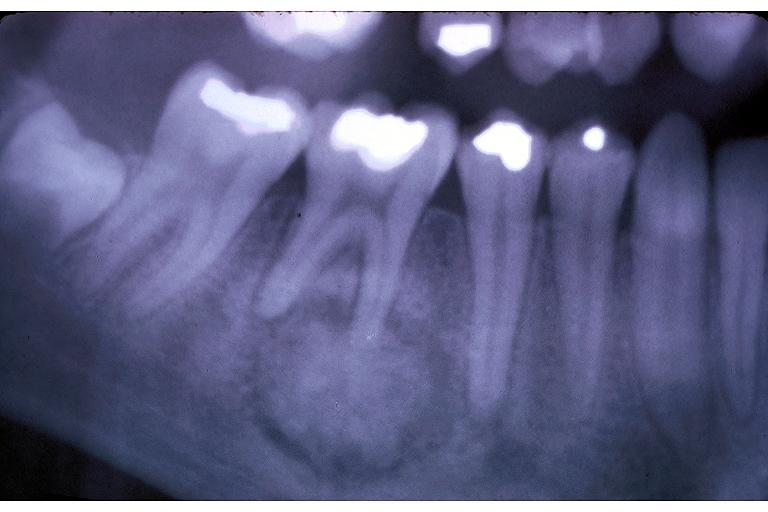s bone marrow present?
Answer the question using a single word or phrase. No 